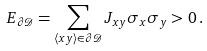<formula> <loc_0><loc_0><loc_500><loc_500>E _ { \partial \mathcal { D } } = \sum _ { \langle x y \rangle \in \partial \mathcal { D } } J _ { x y } \sigma _ { x } \sigma _ { y } > 0 \, .</formula> 